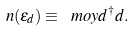<formula> <loc_0><loc_0><loc_500><loc_500>n ( \epsilon _ { d } ) \equiv \ m o y { d ^ { \dagger } d } .</formula> 